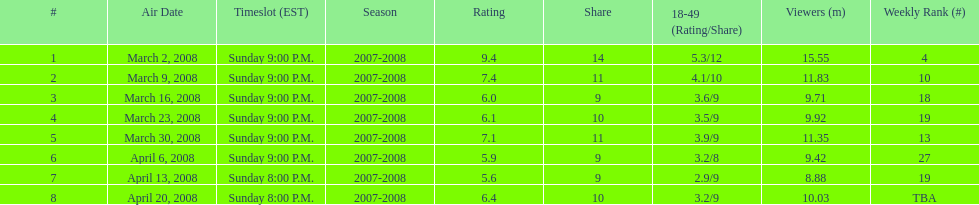On which airing date were there the least number of viewers? April 13, 2008. 